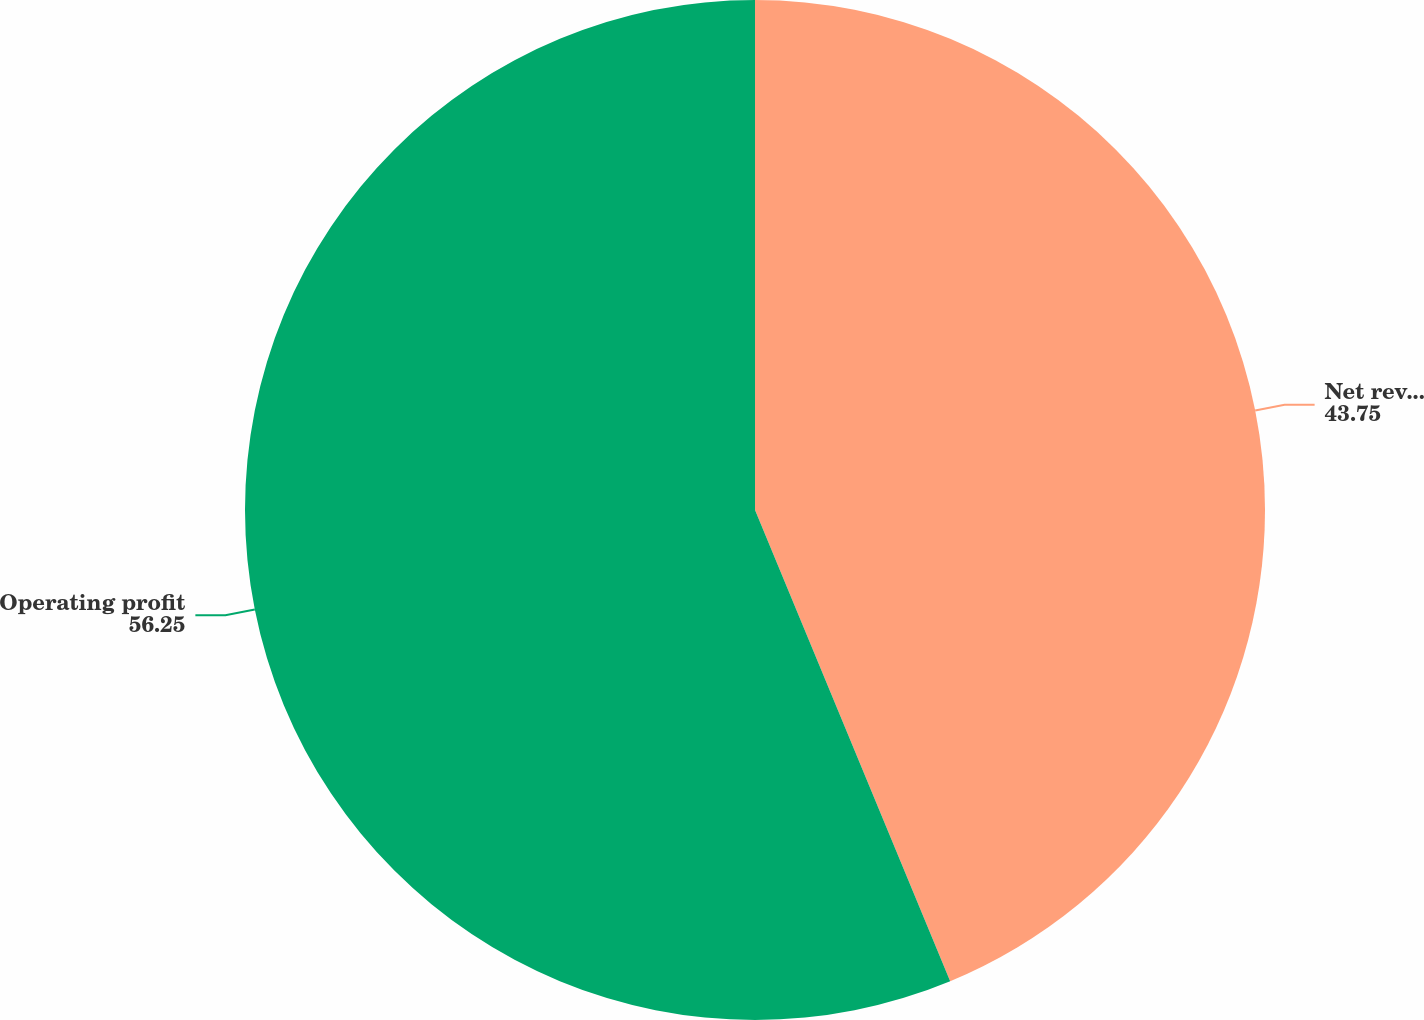Convert chart. <chart><loc_0><loc_0><loc_500><loc_500><pie_chart><fcel>Net revenue<fcel>Operating profit<nl><fcel>43.75%<fcel>56.25%<nl></chart> 